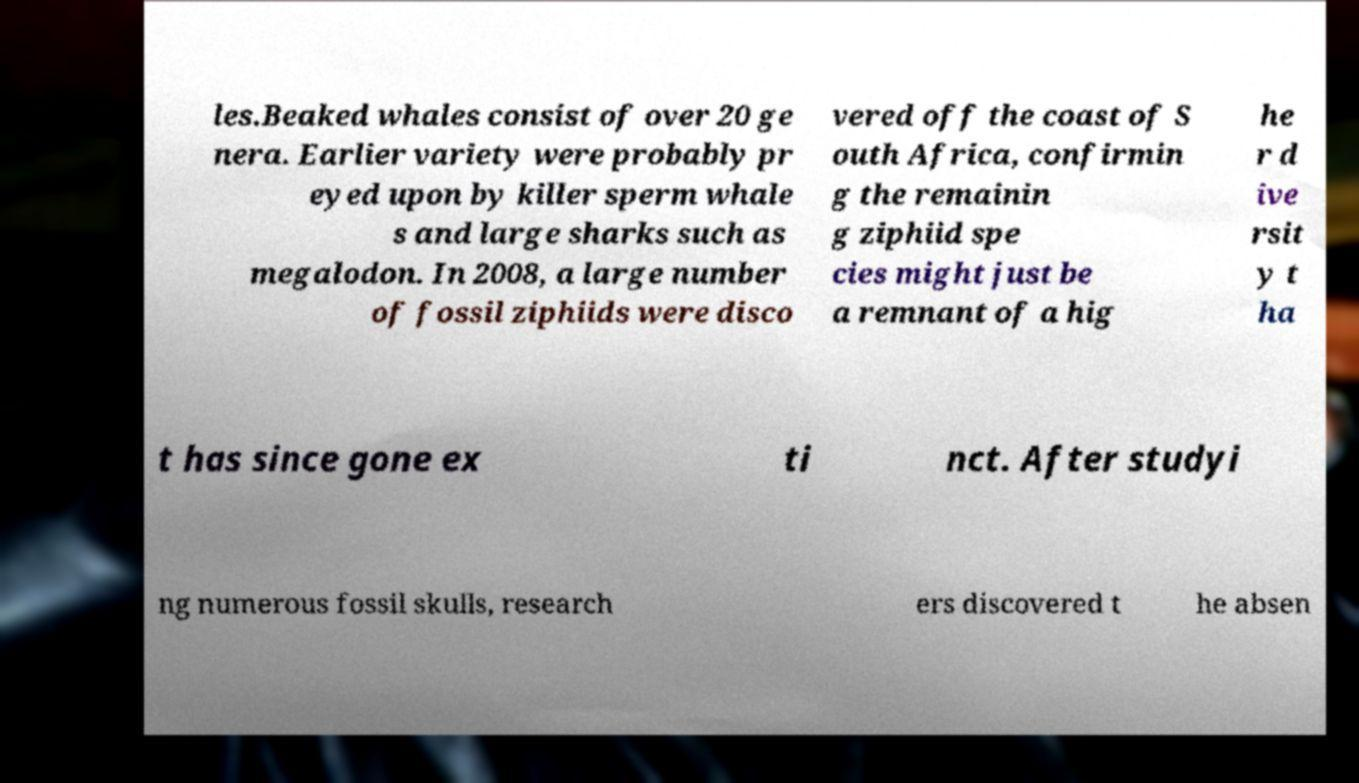Can you accurately transcribe the text from the provided image for me? les.Beaked whales consist of over 20 ge nera. Earlier variety were probably pr eyed upon by killer sperm whale s and large sharks such as megalodon. In 2008, a large number of fossil ziphiids were disco vered off the coast of S outh Africa, confirmin g the remainin g ziphiid spe cies might just be a remnant of a hig he r d ive rsit y t ha t has since gone ex ti nct. After studyi ng numerous fossil skulls, research ers discovered t he absen 